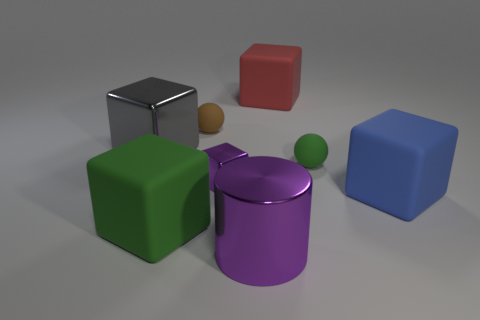Add 1 tiny purple metal objects. How many objects exist? 9 Subtract all big blue rubber cubes. How many cubes are left? 4 Subtract 4 blocks. How many blocks are left? 1 Subtract all cylinders. How many objects are left? 7 Subtract all green blocks. How many blocks are left? 4 Add 8 big red cubes. How many big red cubes exist? 9 Subtract 1 green spheres. How many objects are left? 7 Subtract all cyan balls. Subtract all green cubes. How many balls are left? 2 Subtract all small cyan matte spheres. Subtract all large blocks. How many objects are left? 4 Add 7 green objects. How many green objects are left? 9 